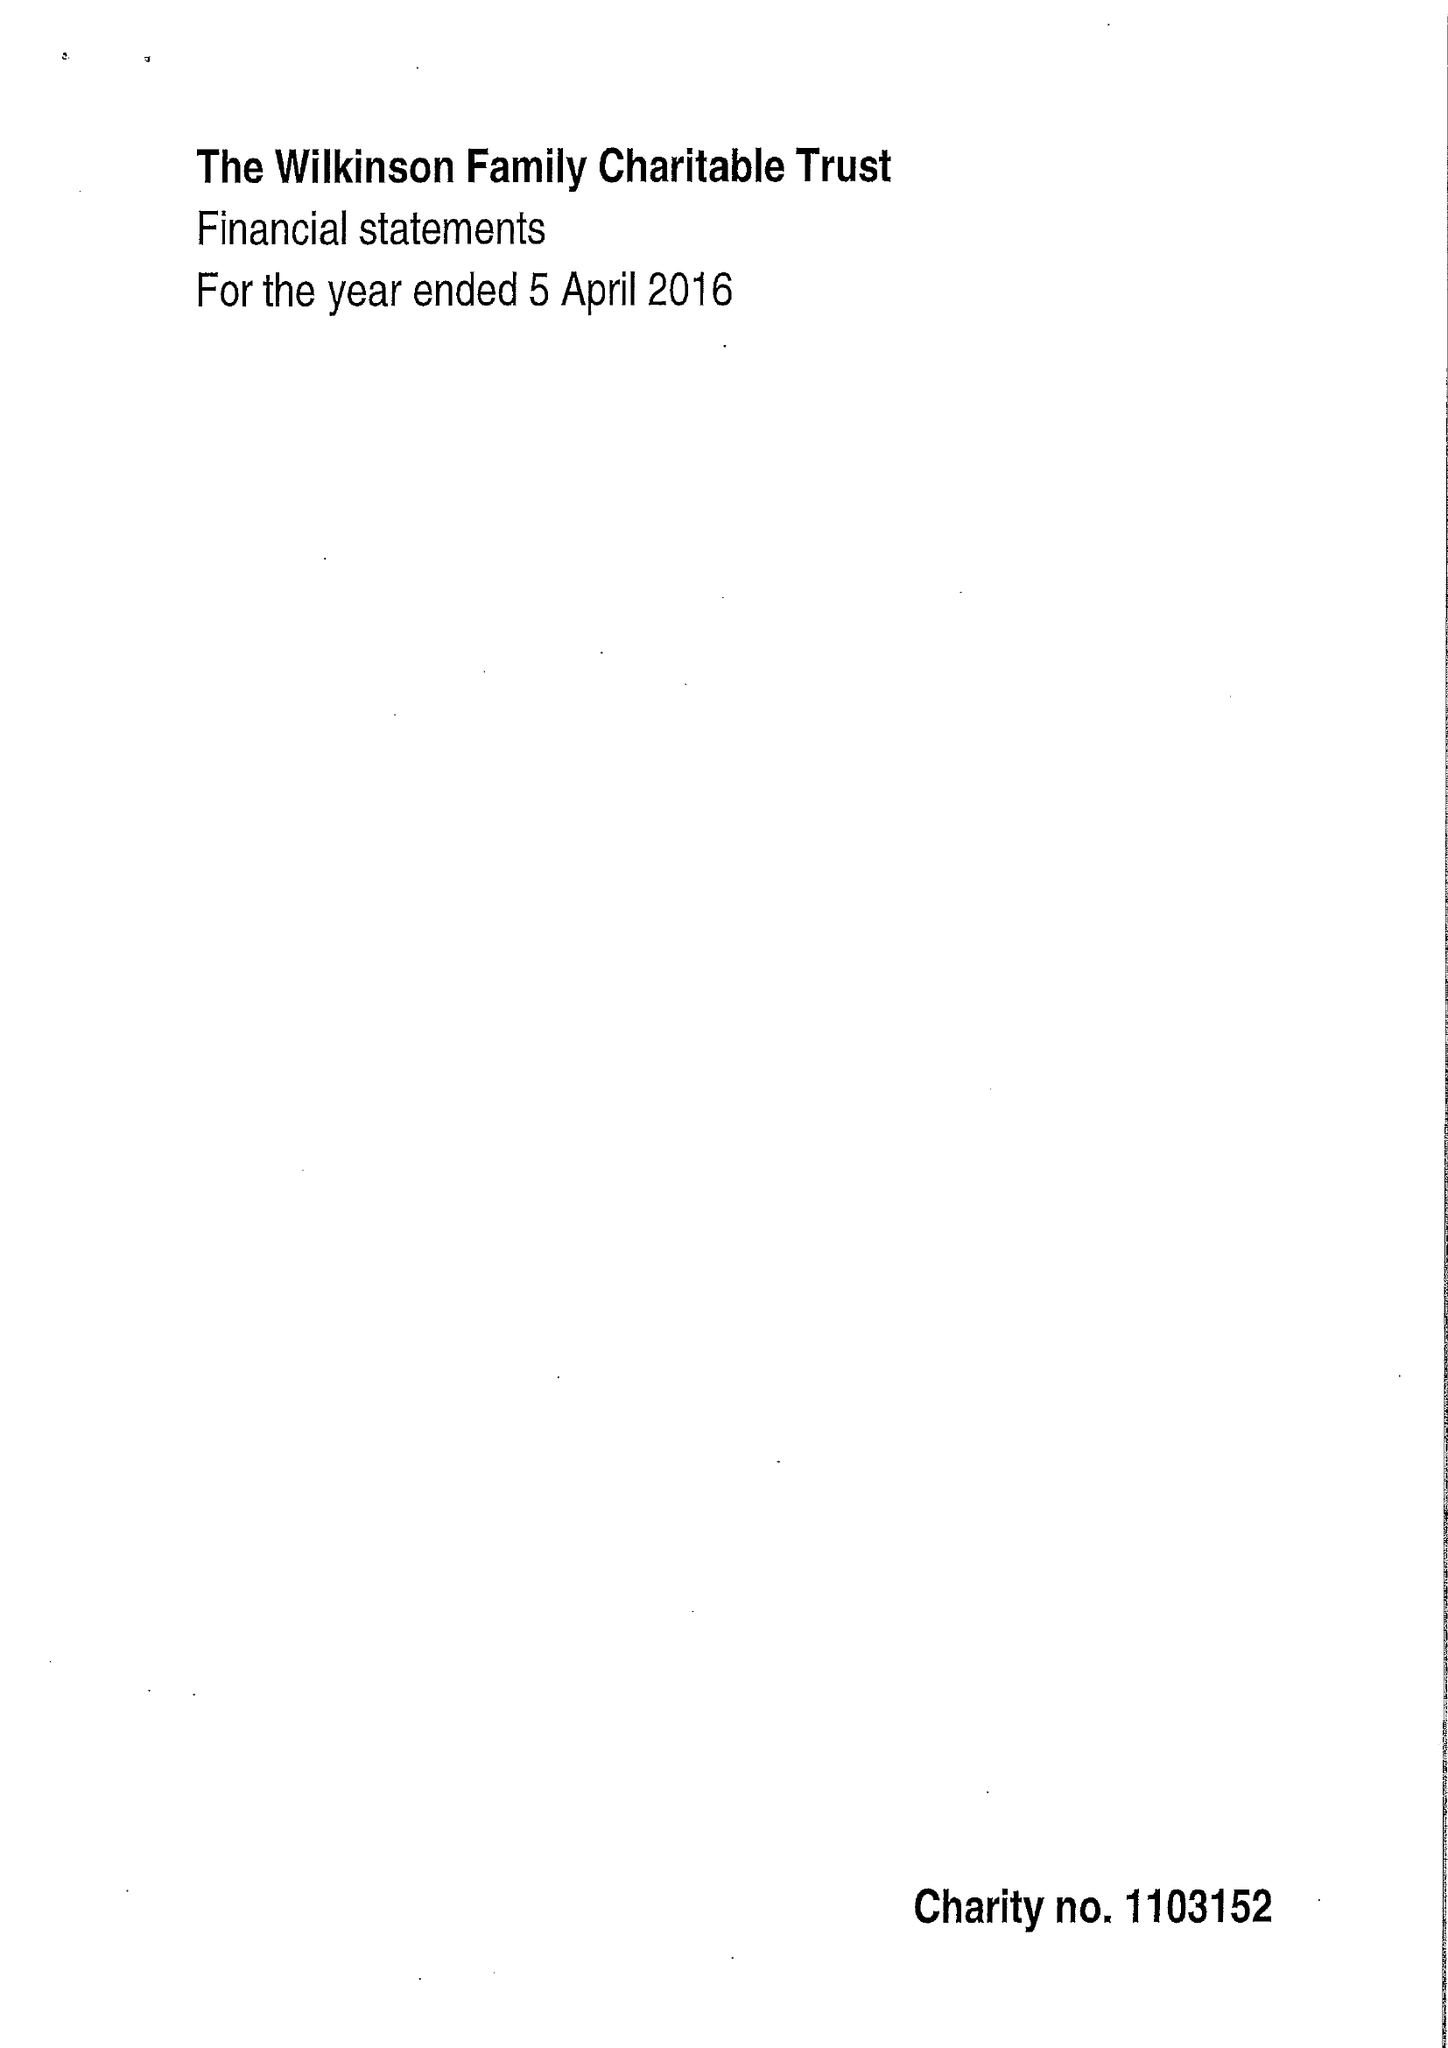What is the value for the income_annually_in_british_pounds?
Answer the question using a single word or phrase. 104707.00 